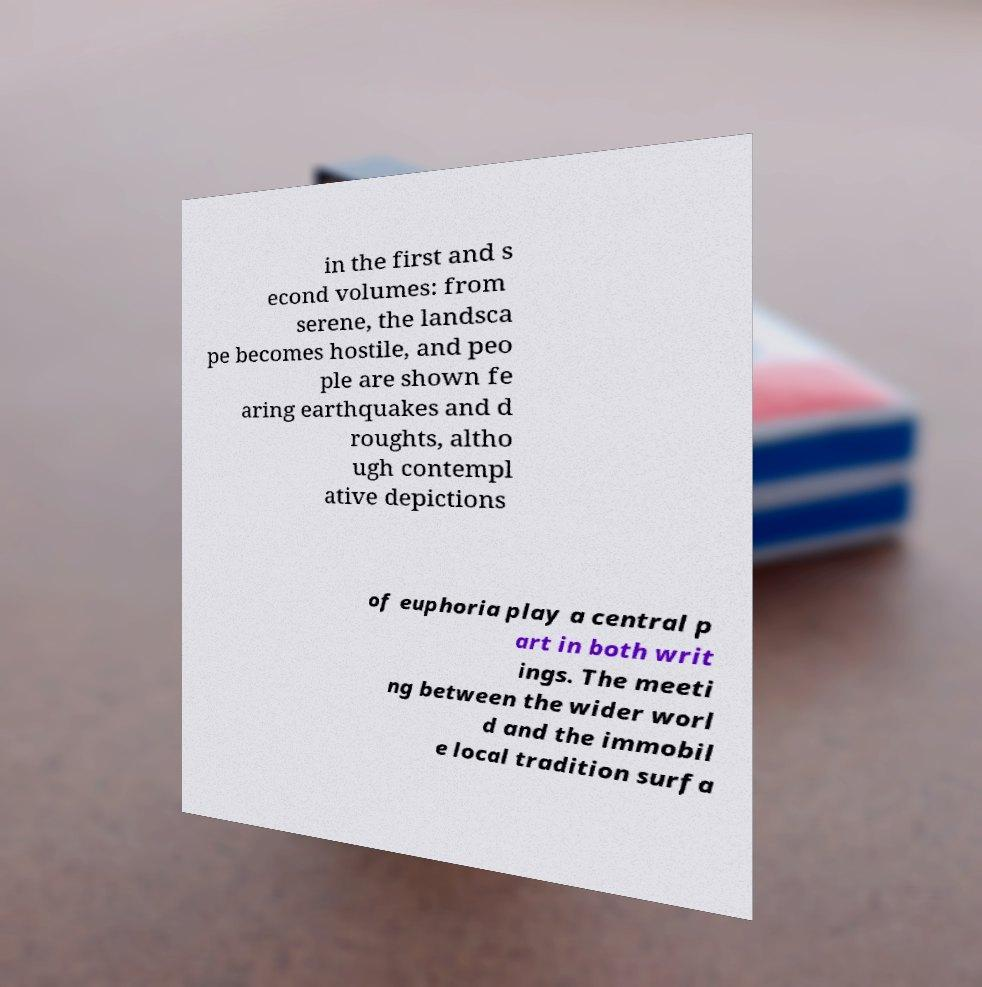Can you accurately transcribe the text from the provided image for me? in the first and s econd volumes: from serene, the landsca pe becomes hostile, and peo ple are shown fe aring earthquakes and d roughts, altho ugh contempl ative depictions of euphoria play a central p art in both writ ings. The meeti ng between the wider worl d and the immobil e local tradition surfa 